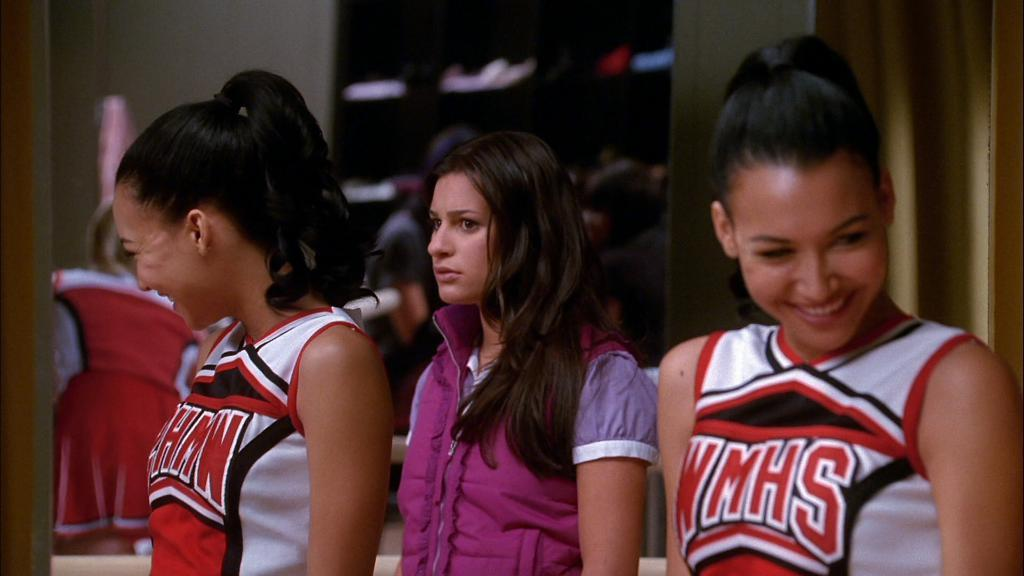<image>
Write a terse but informative summary of the picture. the name WMHS that is on a cheer jersey 